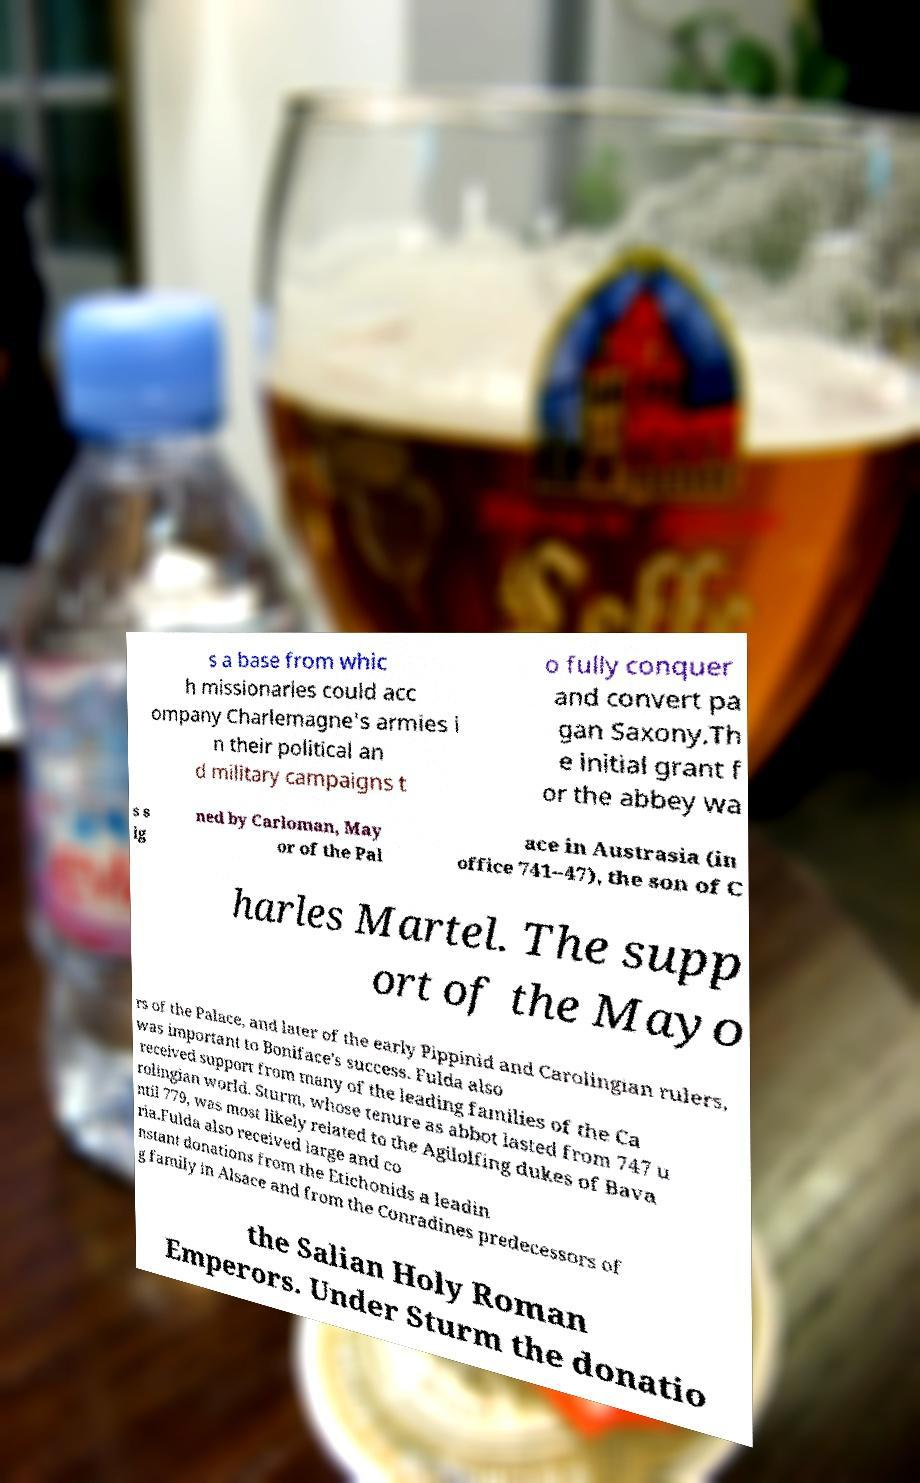For documentation purposes, I need the text within this image transcribed. Could you provide that? s a base from whic h missionaries could acc ompany Charlemagne's armies i n their political an d military campaigns t o fully conquer and convert pa gan Saxony.Th e initial grant f or the abbey wa s s ig ned by Carloman, May or of the Pal ace in Austrasia (in office 741–47), the son of C harles Martel. The supp ort of the Mayo rs of the Palace, and later of the early Pippinid and Carolingian rulers, was important to Boniface's success. Fulda also received support from many of the leading families of the Ca rolingian world. Sturm, whose tenure as abbot lasted from 747 u ntil 779, was most likely related to the Agilolfing dukes of Bava ria.Fulda also received large and co nstant donations from the Etichonids a leadin g family in Alsace and from the Conradines predecessors of the Salian Holy Roman Emperors. Under Sturm the donatio 